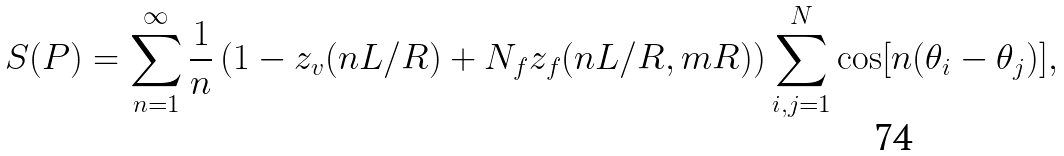<formula> <loc_0><loc_0><loc_500><loc_500>S ( P ) = \sum _ { n = 1 } ^ { \infty } \frac { 1 } { n } \left ( 1 - z _ { v } ( n L / R ) + N _ { f } z _ { f } ( n L / R , m R ) \right ) \sum _ { i , j = 1 } ^ { N } \cos [ n ( \theta _ { i } - \theta _ { j } ) ] ,</formula> 